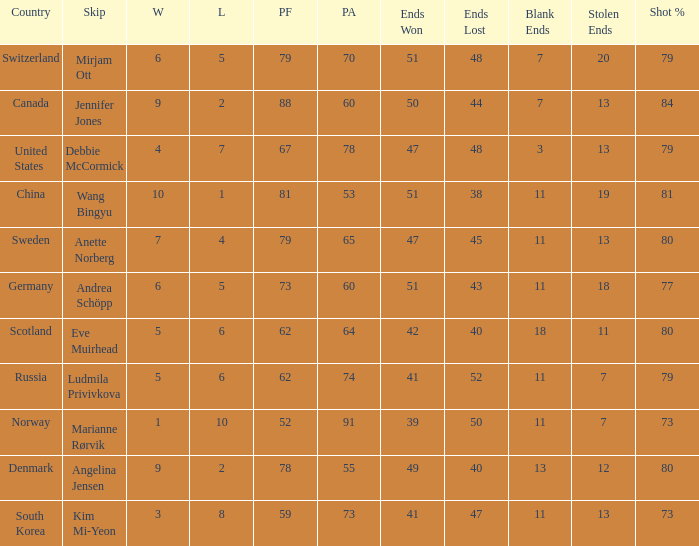What is Norway's least ends lost? 50.0. 